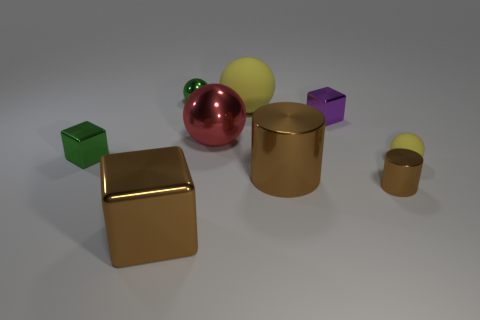There is a green thing in front of the red thing; does it have the same shape as the tiny rubber thing? no 